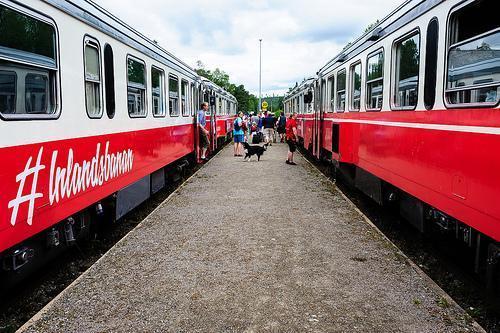How many trains are there?
Give a very brief answer. 2. 